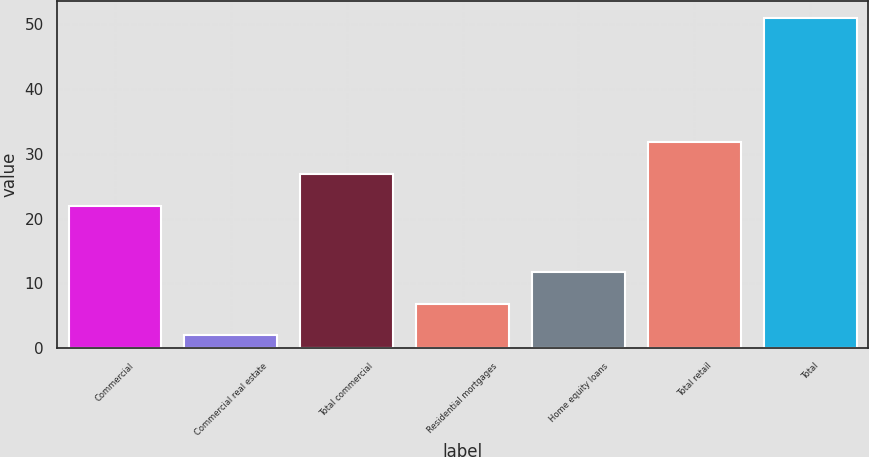Convert chart. <chart><loc_0><loc_0><loc_500><loc_500><bar_chart><fcel>Commercial<fcel>Commercial real estate<fcel>Total commercial<fcel>Residential mortgages<fcel>Home equity loans<fcel>Total retail<fcel>Total<nl><fcel>22<fcel>2<fcel>26.9<fcel>6.9<fcel>11.8<fcel>31.8<fcel>51<nl></chart> 